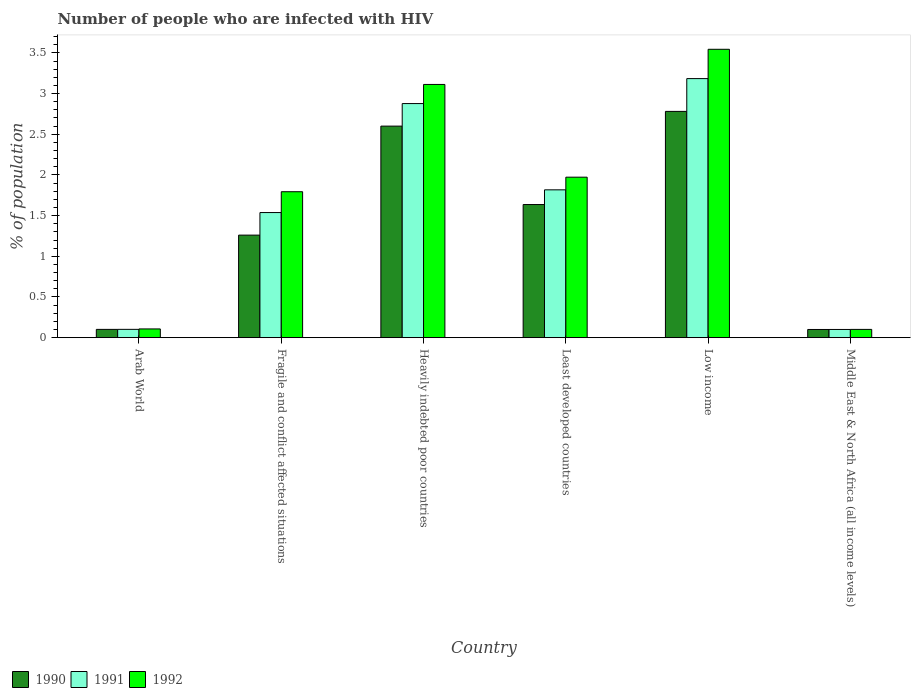Are the number of bars per tick equal to the number of legend labels?
Your response must be concise. Yes. What is the label of the 6th group of bars from the left?
Offer a terse response. Middle East & North Africa (all income levels). What is the percentage of HIV infected population in in 1991 in Low income?
Offer a terse response. 3.18. Across all countries, what is the maximum percentage of HIV infected population in in 1991?
Your answer should be compact. 3.18. Across all countries, what is the minimum percentage of HIV infected population in in 1991?
Offer a very short reply. 0.1. In which country was the percentage of HIV infected population in in 1990 minimum?
Offer a terse response. Middle East & North Africa (all income levels). What is the total percentage of HIV infected population in in 1992 in the graph?
Ensure brevity in your answer.  10.63. What is the difference between the percentage of HIV infected population in in 1991 in Arab World and that in Fragile and conflict affected situations?
Keep it short and to the point. -1.44. What is the difference between the percentage of HIV infected population in in 1991 in Arab World and the percentage of HIV infected population in in 1992 in Heavily indebted poor countries?
Your answer should be compact. -3.01. What is the average percentage of HIV infected population in in 1992 per country?
Your response must be concise. 1.77. What is the difference between the percentage of HIV infected population in of/in 1992 and percentage of HIV infected population in of/in 1990 in Heavily indebted poor countries?
Offer a terse response. 0.51. In how many countries, is the percentage of HIV infected population in in 1990 greater than 2.3 %?
Offer a very short reply. 2. What is the ratio of the percentage of HIV infected population in in 1992 in Fragile and conflict affected situations to that in Low income?
Offer a terse response. 0.51. Is the percentage of HIV infected population in in 1990 in Low income less than that in Middle East & North Africa (all income levels)?
Offer a terse response. No. Is the difference between the percentage of HIV infected population in in 1992 in Arab World and Heavily indebted poor countries greater than the difference between the percentage of HIV infected population in in 1990 in Arab World and Heavily indebted poor countries?
Your answer should be very brief. No. What is the difference between the highest and the second highest percentage of HIV infected population in in 1991?
Keep it short and to the point. -1.06. What is the difference between the highest and the lowest percentage of HIV infected population in in 1990?
Your answer should be very brief. 2.68. How many bars are there?
Provide a succinct answer. 18. Are all the bars in the graph horizontal?
Make the answer very short. No. What is the difference between two consecutive major ticks on the Y-axis?
Your answer should be very brief. 0.5. Does the graph contain grids?
Give a very brief answer. No. Where does the legend appear in the graph?
Offer a very short reply. Bottom left. What is the title of the graph?
Provide a succinct answer. Number of people who are infected with HIV. What is the label or title of the X-axis?
Give a very brief answer. Country. What is the label or title of the Y-axis?
Make the answer very short. % of population. What is the % of population in 1990 in Arab World?
Provide a short and direct response. 0.1. What is the % of population in 1991 in Arab World?
Offer a very short reply. 0.1. What is the % of population of 1992 in Arab World?
Ensure brevity in your answer.  0.11. What is the % of population in 1990 in Fragile and conflict affected situations?
Ensure brevity in your answer.  1.26. What is the % of population in 1991 in Fragile and conflict affected situations?
Your answer should be compact. 1.54. What is the % of population of 1992 in Fragile and conflict affected situations?
Give a very brief answer. 1.79. What is the % of population of 1990 in Heavily indebted poor countries?
Your answer should be very brief. 2.6. What is the % of population of 1991 in Heavily indebted poor countries?
Give a very brief answer. 2.88. What is the % of population in 1992 in Heavily indebted poor countries?
Provide a succinct answer. 3.11. What is the % of population in 1990 in Least developed countries?
Provide a short and direct response. 1.64. What is the % of population in 1991 in Least developed countries?
Your response must be concise. 1.82. What is the % of population of 1992 in Least developed countries?
Give a very brief answer. 1.97. What is the % of population of 1990 in Low income?
Offer a terse response. 2.78. What is the % of population in 1991 in Low income?
Provide a succinct answer. 3.18. What is the % of population of 1992 in Low income?
Keep it short and to the point. 3.54. What is the % of population of 1990 in Middle East & North Africa (all income levels)?
Make the answer very short. 0.1. What is the % of population of 1991 in Middle East & North Africa (all income levels)?
Make the answer very short. 0.1. What is the % of population of 1992 in Middle East & North Africa (all income levels)?
Provide a succinct answer. 0.1. Across all countries, what is the maximum % of population of 1990?
Ensure brevity in your answer.  2.78. Across all countries, what is the maximum % of population of 1991?
Your answer should be very brief. 3.18. Across all countries, what is the maximum % of population of 1992?
Offer a terse response. 3.54. Across all countries, what is the minimum % of population in 1990?
Your answer should be compact. 0.1. Across all countries, what is the minimum % of population of 1991?
Offer a terse response. 0.1. Across all countries, what is the minimum % of population in 1992?
Ensure brevity in your answer.  0.1. What is the total % of population in 1990 in the graph?
Offer a terse response. 8.48. What is the total % of population in 1991 in the graph?
Provide a succinct answer. 9.62. What is the total % of population of 1992 in the graph?
Provide a succinct answer. 10.63. What is the difference between the % of population in 1990 in Arab World and that in Fragile and conflict affected situations?
Offer a very short reply. -1.16. What is the difference between the % of population of 1991 in Arab World and that in Fragile and conflict affected situations?
Give a very brief answer. -1.44. What is the difference between the % of population of 1992 in Arab World and that in Fragile and conflict affected situations?
Offer a terse response. -1.69. What is the difference between the % of population of 1990 in Arab World and that in Heavily indebted poor countries?
Offer a very short reply. -2.5. What is the difference between the % of population of 1991 in Arab World and that in Heavily indebted poor countries?
Offer a very short reply. -2.77. What is the difference between the % of population in 1992 in Arab World and that in Heavily indebted poor countries?
Give a very brief answer. -3. What is the difference between the % of population in 1990 in Arab World and that in Least developed countries?
Give a very brief answer. -1.53. What is the difference between the % of population in 1991 in Arab World and that in Least developed countries?
Your response must be concise. -1.71. What is the difference between the % of population of 1992 in Arab World and that in Least developed countries?
Your answer should be compact. -1.87. What is the difference between the % of population of 1990 in Arab World and that in Low income?
Your answer should be very brief. -2.68. What is the difference between the % of population of 1991 in Arab World and that in Low income?
Give a very brief answer. -3.08. What is the difference between the % of population in 1992 in Arab World and that in Low income?
Give a very brief answer. -3.44. What is the difference between the % of population in 1990 in Arab World and that in Middle East & North Africa (all income levels)?
Your answer should be very brief. 0. What is the difference between the % of population in 1991 in Arab World and that in Middle East & North Africa (all income levels)?
Ensure brevity in your answer.  0. What is the difference between the % of population of 1992 in Arab World and that in Middle East & North Africa (all income levels)?
Give a very brief answer. 0.01. What is the difference between the % of population in 1990 in Fragile and conflict affected situations and that in Heavily indebted poor countries?
Your answer should be very brief. -1.34. What is the difference between the % of population of 1991 in Fragile and conflict affected situations and that in Heavily indebted poor countries?
Give a very brief answer. -1.34. What is the difference between the % of population of 1992 in Fragile and conflict affected situations and that in Heavily indebted poor countries?
Your answer should be very brief. -1.32. What is the difference between the % of population in 1990 in Fragile and conflict affected situations and that in Least developed countries?
Offer a terse response. -0.38. What is the difference between the % of population of 1991 in Fragile and conflict affected situations and that in Least developed countries?
Ensure brevity in your answer.  -0.28. What is the difference between the % of population of 1992 in Fragile and conflict affected situations and that in Least developed countries?
Offer a terse response. -0.18. What is the difference between the % of population of 1990 in Fragile and conflict affected situations and that in Low income?
Provide a short and direct response. -1.52. What is the difference between the % of population of 1991 in Fragile and conflict affected situations and that in Low income?
Offer a terse response. -1.65. What is the difference between the % of population of 1992 in Fragile and conflict affected situations and that in Low income?
Make the answer very short. -1.75. What is the difference between the % of population in 1990 in Fragile and conflict affected situations and that in Middle East & North Africa (all income levels)?
Your answer should be very brief. 1.16. What is the difference between the % of population in 1991 in Fragile and conflict affected situations and that in Middle East & North Africa (all income levels)?
Make the answer very short. 1.44. What is the difference between the % of population in 1992 in Fragile and conflict affected situations and that in Middle East & North Africa (all income levels)?
Provide a succinct answer. 1.69. What is the difference between the % of population in 1990 in Heavily indebted poor countries and that in Least developed countries?
Your answer should be compact. 0.96. What is the difference between the % of population of 1991 in Heavily indebted poor countries and that in Least developed countries?
Make the answer very short. 1.06. What is the difference between the % of population of 1992 in Heavily indebted poor countries and that in Least developed countries?
Make the answer very short. 1.14. What is the difference between the % of population of 1990 in Heavily indebted poor countries and that in Low income?
Make the answer very short. -0.18. What is the difference between the % of population of 1991 in Heavily indebted poor countries and that in Low income?
Keep it short and to the point. -0.31. What is the difference between the % of population in 1992 in Heavily indebted poor countries and that in Low income?
Give a very brief answer. -0.43. What is the difference between the % of population in 1990 in Heavily indebted poor countries and that in Middle East & North Africa (all income levels)?
Your response must be concise. 2.5. What is the difference between the % of population of 1991 in Heavily indebted poor countries and that in Middle East & North Africa (all income levels)?
Offer a terse response. 2.78. What is the difference between the % of population in 1992 in Heavily indebted poor countries and that in Middle East & North Africa (all income levels)?
Provide a short and direct response. 3.01. What is the difference between the % of population in 1990 in Least developed countries and that in Low income?
Ensure brevity in your answer.  -1.14. What is the difference between the % of population of 1991 in Least developed countries and that in Low income?
Give a very brief answer. -1.37. What is the difference between the % of population in 1992 in Least developed countries and that in Low income?
Make the answer very short. -1.57. What is the difference between the % of population of 1990 in Least developed countries and that in Middle East & North Africa (all income levels)?
Provide a succinct answer. 1.54. What is the difference between the % of population of 1991 in Least developed countries and that in Middle East & North Africa (all income levels)?
Keep it short and to the point. 1.72. What is the difference between the % of population of 1992 in Least developed countries and that in Middle East & North Africa (all income levels)?
Your answer should be very brief. 1.87. What is the difference between the % of population of 1990 in Low income and that in Middle East & North Africa (all income levels)?
Your answer should be compact. 2.68. What is the difference between the % of population in 1991 in Low income and that in Middle East & North Africa (all income levels)?
Your answer should be very brief. 3.08. What is the difference between the % of population in 1992 in Low income and that in Middle East & North Africa (all income levels)?
Provide a short and direct response. 3.44. What is the difference between the % of population in 1990 in Arab World and the % of population in 1991 in Fragile and conflict affected situations?
Give a very brief answer. -1.44. What is the difference between the % of population of 1990 in Arab World and the % of population of 1992 in Fragile and conflict affected situations?
Your answer should be compact. -1.69. What is the difference between the % of population of 1991 in Arab World and the % of population of 1992 in Fragile and conflict affected situations?
Provide a succinct answer. -1.69. What is the difference between the % of population of 1990 in Arab World and the % of population of 1991 in Heavily indebted poor countries?
Offer a very short reply. -2.78. What is the difference between the % of population of 1990 in Arab World and the % of population of 1992 in Heavily indebted poor countries?
Offer a very short reply. -3.01. What is the difference between the % of population of 1991 in Arab World and the % of population of 1992 in Heavily indebted poor countries?
Provide a succinct answer. -3.01. What is the difference between the % of population of 1990 in Arab World and the % of population of 1991 in Least developed countries?
Your answer should be compact. -1.72. What is the difference between the % of population of 1990 in Arab World and the % of population of 1992 in Least developed countries?
Ensure brevity in your answer.  -1.87. What is the difference between the % of population of 1991 in Arab World and the % of population of 1992 in Least developed countries?
Provide a short and direct response. -1.87. What is the difference between the % of population of 1990 in Arab World and the % of population of 1991 in Low income?
Give a very brief answer. -3.08. What is the difference between the % of population of 1990 in Arab World and the % of population of 1992 in Low income?
Offer a terse response. -3.44. What is the difference between the % of population of 1991 in Arab World and the % of population of 1992 in Low income?
Your response must be concise. -3.44. What is the difference between the % of population in 1990 in Arab World and the % of population in 1991 in Middle East & North Africa (all income levels)?
Make the answer very short. 0. What is the difference between the % of population in 1991 in Arab World and the % of population in 1992 in Middle East & North Africa (all income levels)?
Ensure brevity in your answer.  0. What is the difference between the % of population in 1990 in Fragile and conflict affected situations and the % of population in 1991 in Heavily indebted poor countries?
Provide a short and direct response. -1.62. What is the difference between the % of population of 1990 in Fragile and conflict affected situations and the % of population of 1992 in Heavily indebted poor countries?
Keep it short and to the point. -1.85. What is the difference between the % of population of 1991 in Fragile and conflict affected situations and the % of population of 1992 in Heavily indebted poor countries?
Keep it short and to the point. -1.57. What is the difference between the % of population of 1990 in Fragile and conflict affected situations and the % of population of 1991 in Least developed countries?
Your answer should be compact. -0.56. What is the difference between the % of population in 1990 in Fragile and conflict affected situations and the % of population in 1992 in Least developed countries?
Your response must be concise. -0.71. What is the difference between the % of population of 1991 in Fragile and conflict affected situations and the % of population of 1992 in Least developed countries?
Give a very brief answer. -0.43. What is the difference between the % of population of 1990 in Fragile and conflict affected situations and the % of population of 1991 in Low income?
Keep it short and to the point. -1.92. What is the difference between the % of population in 1990 in Fragile and conflict affected situations and the % of population in 1992 in Low income?
Ensure brevity in your answer.  -2.28. What is the difference between the % of population in 1991 in Fragile and conflict affected situations and the % of population in 1992 in Low income?
Ensure brevity in your answer.  -2.01. What is the difference between the % of population in 1990 in Fragile and conflict affected situations and the % of population in 1991 in Middle East & North Africa (all income levels)?
Offer a terse response. 1.16. What is the difference between the % of population of 1990 in Fragile and conflict affected situations and the % of population of 1992 in Middle East & North Africa (all income levels)?
Offer a very short reply. 1.16. What is the difference between the % of population of 1991 in Fragile and conflict affected situations and the % of population of 1992 in Middle East & North Africa (all income levels)?
Give a very brief answer. 1.44. What is the difference between the % of population of 1990 in Heavily indebted poor countries and the % of population of 1991 in Least developed countries?
Offer a very short reply. 0.78. What is the difference between the % of population of 1990 in Heavily indebted poor countries and the % of population of 1992 in Least developed countries?
Offer a very short reply. 0.63. What is the difference between the % of population in 1991 in Heavily indebted poor countries and the % of population in 1992 in Least developed countries?
Your answer should be compact. 0.9. What is the difference between the % of population of 1990 in Heavily indebted poor countries and the % of population of 1991 in Low income?
Provide a short and direct response. -0.58. What is the difference between the % of population in 1990 in Heavily indebted poor countries and the % of population in 1992 in Low income?
Offer a terse response. -0.94. What is the difference between the % of population of 1991 in Heavily indebted poor countries and the % of population of 1992 in Low income?
Ensure brevity in your answer.  -0.67. What is the difference between the % of population in 1990 in Heavily indebted poor countries and the % of population in 1991 in Middle East & North Africa (all income levels)?
Offer a very short reply. 2.5. What is the difference between the % of population in 1990 in Heavily indebted poor countries and the % of population in 1992 in Middle East & North Africa (all income levels)?
Provide a short and direct response. 2.5. What is the difference between the % of population in 1991 in Heavily indebted poor countries and the % of population in 1992 in Middle East & North Africa (all income levels)?
Your answer should be compact. 2.78. What is the difference between the % of population in 1990 in Least developed countries and the % of population in 1991 in Low income?
Offer a very short reply. -1.55. What is the difference between the % of population of 1990 in Least developed countries and the % of population of 1992 in Low income?
Make the answer very short. -1.91. What is the difference between the % of population of 1991 in Least developed countries and the % of population of 1992 in Low income?
Provide a succinct answer. -1.73. What is the difference between the % of population in 1990 in Least developed countries and the % of population in 1991 in Middle East & North Africa (all income levels)?
Provide a succinct answer. 1.54. What is the difference between the % of population of 1990 in Least developed countries and the % of population of 1992 in Middle East & North Africa (all income levels)?
Make the answer very short. 1.53. What is the difference between the % of population of 1991 in Least developed countries and the % of population of 1992 in Middle East & North Africa (all income levels)?
Ensure brevity in your answer.  1.72. What is the difference between the % of population in 1990 in Low income and the % of population in 1991 in Middle East & North Africa (all income levels)?
Make the answer very short. 2.68. What is the difference between the % of population of 1990 in Low income and the % of population of 1992 in Middle East & North Africa (all income levels)?
Keep it short and to the point. 2.68. What is the difference between the % of population of 1991 in Low income and the % of population of 1992 in Middle East & North Africa (all income levels)?
Offer a very short reply. 3.08. What is the average % of population in 1990 per country?
Your answer should be compact. 1.41. What is the average % of population in 1991 per country?
Give a very brief answer. 1.6. What is the average % of population in 1992 per country?
Make the answer very short. 1.77. What is the difference between the % of population in 1990 and % of population in 1991 in Arab World?
Your response must be concise. -0. What is the difference between the % of population in 1990 and % of population in 1992 in Arab World?
Your response must be concise. -0.01. What is the difference between the % of population of 1991 and % of population of 1992 in Arab World?
Make the answer very short. -0.01. What is the difference between the % of population of 1990 and % of population of 1991 in Fragile and conflict affected situations?
Keep it short and to the point. -0.28. What is the difference between the % of population in 1990 and % of population in 1992 in Fragile and conflict affected situations?
Your response must be concise. -0.53. What is the difference between the % of population of 1991 and % of population of 1992 in Fragile and conflict affected situations?
Keep it short and to the point. -0.26. What is the difference between the % of population of 1990 and % of population of 1991 in Heavily indebted poor countries?
Your answer should be very brief. -0.28. What is the difference between the % of population of 1990 and % of population of 1992 in Heavily indebted poor countries?
Provide a succinct answer. -0.51. What is the difference between the % of population in 1991 and % of population in 1992 in Heavily indebted poor countries?
Offer a terse response. -0.23. What is the difference between the % of population of 1990 and % of population of 1991 in Least developed countries?
Ensure brevity in your answer.  -0.18. What is the difference between the % of population in 1990 and % of population in 1992 in Least developed countries?
Your answer should be compact. -0.34. What is the difference between the % of population in 1991 and % of population in 1992 in Least developed countries?
Your response must be concise. -0.16. What is the difference between the % of population of 1990 and % of population of 1991 in Low income?
Ensure brevity in your answer.  -0.4. What is the difference between the % of population in 1990 and % of population in 1992 in Low income?
Provide a succinct answer. -0.76. What is the difference between the % of population in 1991 and % of population in 1992 in Low income?
Give a very brief answer. -0.36. What is the difference between the % of population in 1990 and % of population in 1991 in Middle East & North Africa (all income levels)?
Provide a short and direct response. -0. What is the difference between the % of population in 1990 and % of population in 1992 in Middle East & North Africa (all income levels)?
Keep it short and to the point. -0. What is the difference between the % of population in 1991 and % of population in 1992 in Middle East & North Africa (all income levels)?
Provide a short and direct response. -0. What is the ratio of the % of population in 1990 in Arab World to that in Fragile and conflict affected situations?
Your answer should be very brief. 0.08. What is the ratio of the % of population of 1991 in Arab World to that in Fragile and conflict affected situations?
Offer a terse response. 0.07. What is the ratio of the % of population of 1992 in Arab World to that in Fragile and conflict affected situations?
Provide a short and direct response. 0.06. What is the ratio of the % of population of 1990 in Arab World to that in Heavily indebted poor countries?
Provide a succinct answer. 0.04. What is the ratio of the % of population of 1991 in Arab World to that in Heavily indebted poor countries?
Offer a terse response. 0.04. What is the ratio of the % of population of 1992 in Arab World to that in Heavily indebted poor countries?
Your response must be concise. 0.03. What is the ratio of the % of population of 1990 in Arab World to that in Least developed countries?
Provide a succinct answer. 0.06. What is the ratio of the % of population in 1991 in Arab World to that in Least developed countries?
Offer a terse response. 0.06. What is the ratio of the % of population of 1992 in Arab World to that in Least developed countries?
Your response must be concise. 0.05. What is the ratio of the % of population in 1990 in Arab World to that in Low income?
Your answer should be compact. 0.04. What is the ratio of the % of population in 1991 in Arab World to that in Low income?
Make the answer very short. 0.03. What is the ratio of the % of population in 1992 in Arab World to that in Low income?
Ensure brevity in your answer.  0.03. What is the ratio of the % of population in 1990 in Arab World to that in Middle East & North Africa (all income levels)?
Offer a very short reply. 1.01. What is the ratio of the % of population in 1991 in Arab World to that in Middle East & North Africa (all income levels)?
Give a very brief answer. 1.01. What is the ratio of the % of population of 1992 in Arab World to that in Middle East & North Africa (all income levels)?
Provide a succinct answer. 1.06. What is the ratio of the % of population in 1990 in Fragile and conflict affected situations to that in Heavily indebted poor countries?
Keep it short and to the point. 0.48. What is the ratio of the % of population of 1991 in Fragile and conflict affected situations to that in Heavily indebted poor countries?
Your answer should be very brief. 0.53. What is the ratio of the % of population of 1992 in Fragile and conflict affected situations to that in Heavily indebted poor countries?
Offer a terse response. 0.58. What is the ratio of the % of population in 1990 in Fragile and conflict affected situations to that in Least developed countries?
Your response must be concise. 0.77. What is the ratio of the % of population of 1991 in Fragile and conflict affected situations to that in Least developed countries?
Provide a short and direct response. 0.85. What is the ratio of the % of population in 1992 in Fragile and conflict affected situations to that in Least developed countries?
Offer a terse response. 0.91. What is the ratio of the % of population in 1990 in Fragile and conflict affected situations to that in Low income?
Your answer should be compact. 0.45. What is the ratio of the % of population of 1991 in Fragile and conflict affected situations to that in Low income?
Keep it short and to the point. 0.48. What is the ratio of the % of population of 1992 in Fragile and conflict affected situations to that in Low income?
Provide a succinct answer. 0.51. What is the ratio of the % of population of 1990 in Fragile and conflict affected situations to that in Middle East & North Africa (all income levels)?
Keep it short and to the point. 12.53. What is the ratio of the % of population in 1991 in Fragile and conflict affected situations to that in Middle East & North Africa (all income levels)?
Make the answer very short. 15.24. What is the ratio of the % of population of 1992 in Fragile and conflict affected situations to that in Middle East & North Africa (all income levels)?
Your answer should be very brief. 17.67. What is the ratio of the % of population in 1990 in Heavily indebted poor countries to that in Least developed countries?
Ensure brevity in your answer.  1.59. What is the ratio of the % of population of 1991 in Heavily indebted poor countries to that in Least developed countries?
Offer a terse response. 1.58. What is the ratio of the % of population of 1992 in Heavily indebted poor countries to that in Least developed countries?
Your response must be concise. 1.58. What is the ratio of the % of population of 1990 in Heavily indebted poor countries to that in Low income?
Your response must be concise. 0.94. What is the ratio of the % of population in 1991 in Heavily indebted poor countries to that in Low income?
Provide a succinct answer. 0.9. What is the ratio of the % of population in 1992 in Heavily indebted poor countries to that in Low income?
Ensure brevity in your answer.  0.88. What is the ratio of the % of population of 1990 in Heavily indebted poor countries to that in Middle East & North Africa (all income levels)?
Your answer should be very brief. 25.85. What is the ratio of the % of population of 1991 in Heavily indebted poor countries to that in Middle East & North Africa (all income levels)?
Your response must be concise. 28.52. What is the ratio of the % of population of 1992 in Heavily indebted poor countries to that in Middle East & North Africa (all income levels)?
Your answer should be very brief. 30.66. What is the ratio of the % of population of 1990 in Least developed countries to that in Low income?
Make the answer very short. 0.59. What is the ratio of the % of population in 1991 in Least developed countries to that in Low income?
Your answer should be compact. 0.57. What is the ratio of the % of population in 1992 in Least developed countries to that in Low income?
Your response must be concise. 0.56. What is the ratio of the % of population in 1990 in Least developed countries to that in Middle East & North Africa (all income levels)?
Provide a short and direct response. 16.27. What is the ratio of the % of population of 1991 in Least developed countries to that in Middle East & North Africa (all income levels)?
Provide a short and direct response. 18.01. What is the ratio of the % of population of 1992 in Least developed countries to that in Middle East & North Africa (all income levels)?
Ensure brevity in your answer.  19.43. What is the ratio of the % of population in 1990 in Low income to that in Middle East & North Africa (all income levels)?
Provide a succinct answer. 27.64. What is the ratio of the % of population in 1991 in Low income to that in Middle East & North Africa (all income levels)?
Your answer should be compact. 31.56. What is the ratio of the % of population of 1992 in Low income to that in Middle East & North Africa (all income levels)?
Give a very brief answer. 34.92. What is the difference between the highest and the second highest % of population in 1990?
Ensure brevity in your answer.  0.18. What is the difference between the highest and the second highest % of population in 1991?
Your answer should be very brief. 0.31. What is the difference between the highest and the second highest % of population of 1992?
Offer a very short reply. 0.43. What is the difference between the highest and the lowest % of population in 1990?
Provide a short and direct response. 2.68. What is the difference between the highest and the lowest % of population of 1991?
Your response must be concise. 3.08. What is the difference between the highest and the lowest % of population in 1992?
Your answer should be very brief. 3.44. 